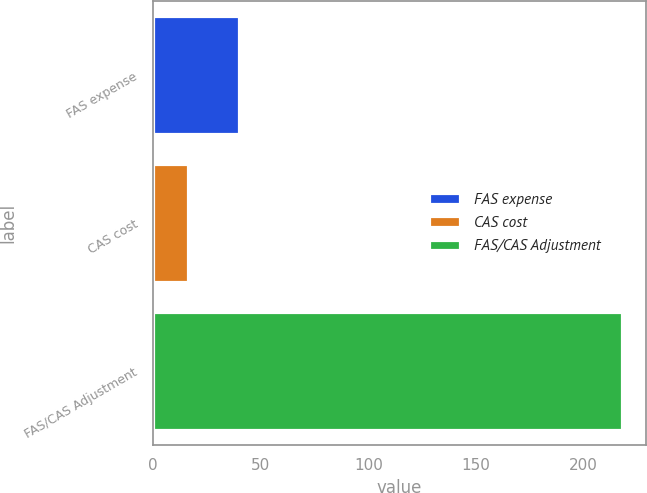Convert chart to OTSL. <chart><loc_0><loc_0><loc_500><loc_500><bar_chart><fcel>FAS expense<fcel>CAS cost<fcel>FAS/CAS Adjustment<nl><fcel>40<fcel>16<fcel>218<nl></chart> 